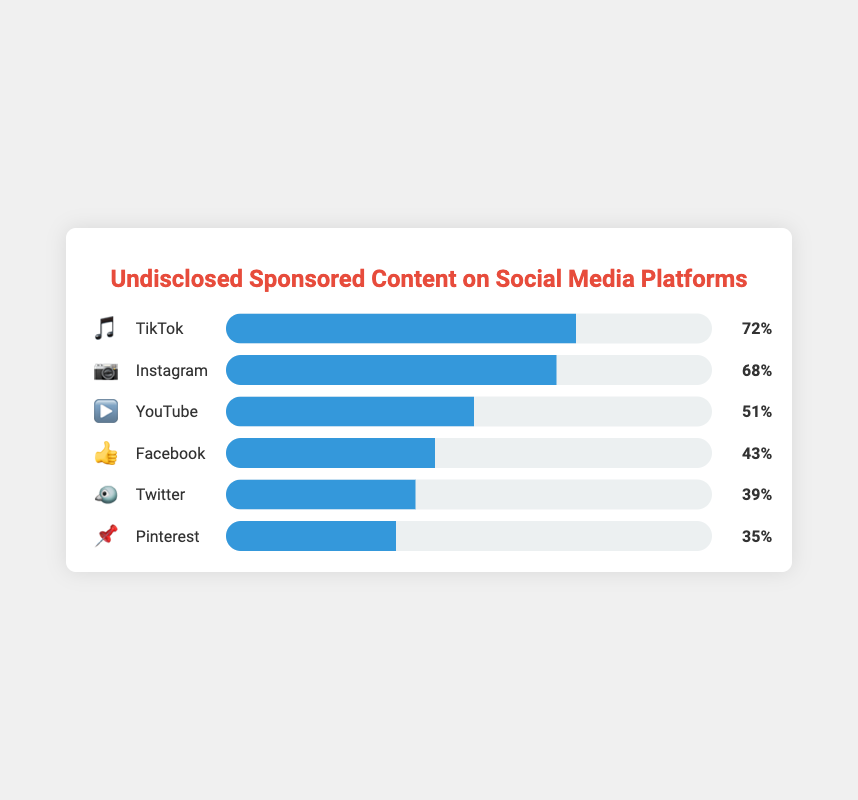What is the title of the chart? The title of the chart is displayed clearly at the top of the figure, right above the visual representation of the data. This title usually provides a summary of what the chart is about.
Answer: Undisclosed Sponsored Content on Social Media Platforms Which platform has the highest percentage of undisclosed sponsored content? To find the platform with the highest percentage, look at the bars and their corresponding percentages. The bar with the greatest length/highest percentage is the one you're looking for.
Answer: TikTok What is the percentage of undisclosed sponsored content on Instagram? Within the chart, each platform has a corresponding percentage displayed. Locate Instagram (indicated by the camera emoji 📷) and read the percentage next to it.
Answer: 68% How do the percentages of Facebook and Twitter compare? Locate the bars for Facebook (👍) and Twitter (🐦) and look at their corresponding percentages. Compare these two numbers directly.
Answer: Facebook has 43%, which is higher than Twitter's 39% What is the average percentage of undisclosed sponsored content across all platforms? To calculate the average, sum all the percentages for the platforms and divide by the number of platforms. The sum is 68 + 72 + 51 + 43 + 39 + 35 = 308. There are 6 platforms. The average is 308/6.
Answer: 51.33% Which platform has the least amount of undisclosed sponsored content? Find the bar with the smallest percentage. The platform with this bar is the one with the least amount of undisclosed sponsored content.
Answer: Pinterest Is the percentage of undisclosed sponsored content higher on Instagram or YouTube? Compare the percentages displayed next to the bars for Instagram (📷) and YouTube (▶️).
Answer: Higher on Instagram (68%) What is the total percentage of undisclosed sponsored content for Facebook, Twitter, and Pinterest combined? Add the percentages of the three platforms: Facebook (43%), Twitter (39%), and Pinterest (35%). 43 + 39 + 35 = 117.
Answer: 117% How many platforms have a percentage of undisclosed sponsored content above 50%? Check each platform's percentage and count how many are greater than 50%. TikTok (72%), Instagram (68%), and YouTube (51%) are above 50%.
Answer: 3 What is the difference in the percentage of undisclosed sponsored content between TikTok and Pinterest? Subtract the percentage of Pinterest (📌) from the percentage of TikTok (🎵). 72 - 35 = 37.
Answer: 37% 